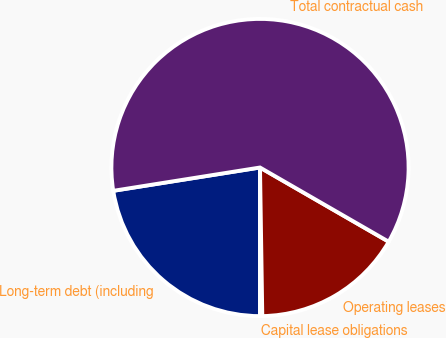Convert chart to OTSL. <chart><loc_0><loc_0><loc_500><loc_500><pie_chart><fcel>Long-term debt (including<fcel>Capital lease obligations<fcel>Operating leases<fcel>Total contractual cash<nl><fcel>22.49%<fcel>0.25%<fcel>16.43%<fcel>60.83%<nl></chart> 